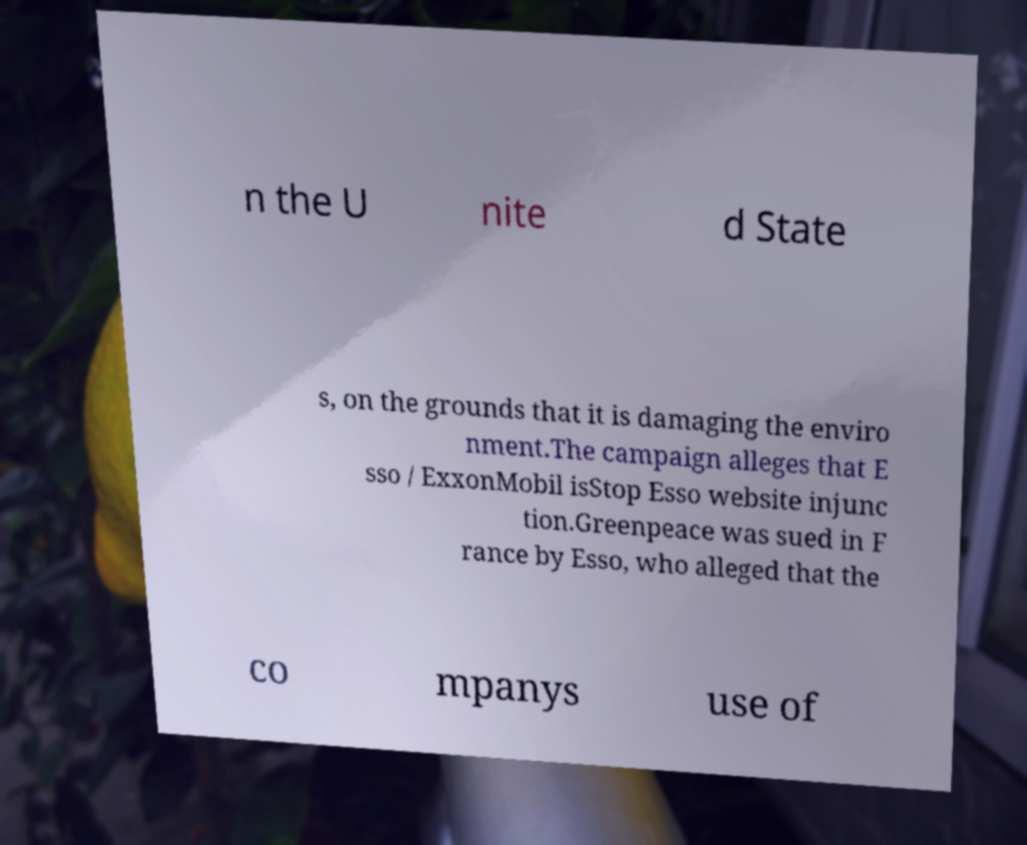Can you accurately transcribe the text from the provided image for me? n the U nite d State s, on the grounds that it is damaging the enviro nment.The campaign alleges that E sso / ExxonMobil isStop Esso website injunc tion.Greenpeace was sued in F rance by Esso, who alleged that the co mpanys use of 